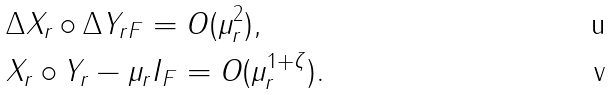<formula> <loc_0><loc_0><loc_500><loc_500>& \| \Delta X _ { r } \circ \Delta Y _ { r } \| _ { F } = O ( \mu _ { r } ^ { 2 } ) , \\ & \| X _ { r } \circ Y _ { r } - \mu _ { r } I \| _ { F } = O ( \mu _ { r } ^ { 1 + \zeta } ) .</formula> 